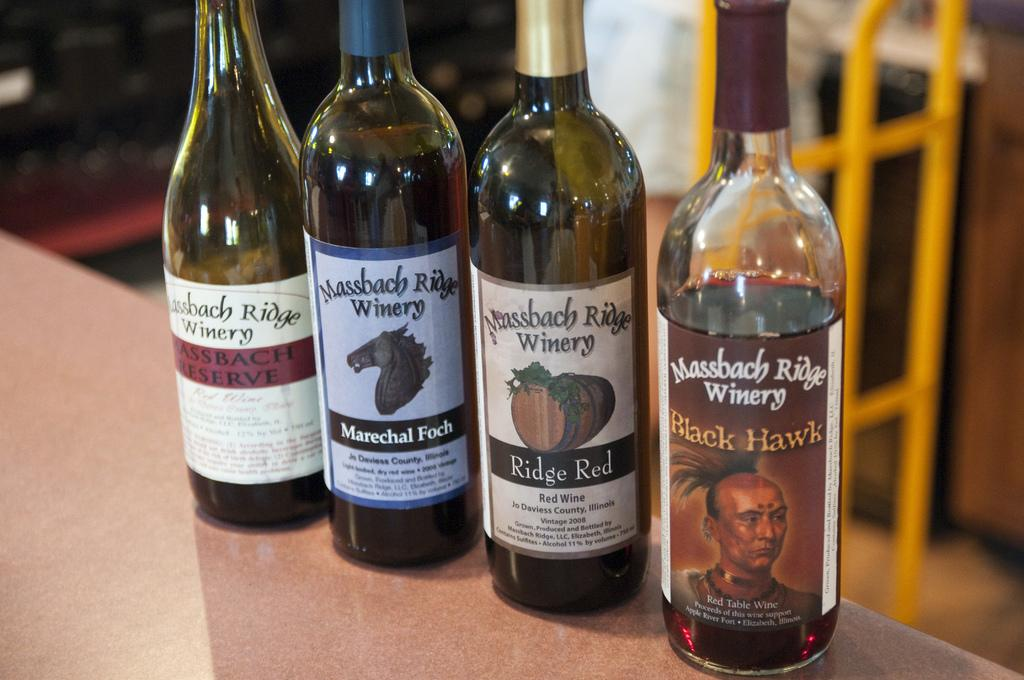<image>
Present a compact description of the photo's key features. four bottles of wine from a place called Massbach ridge 